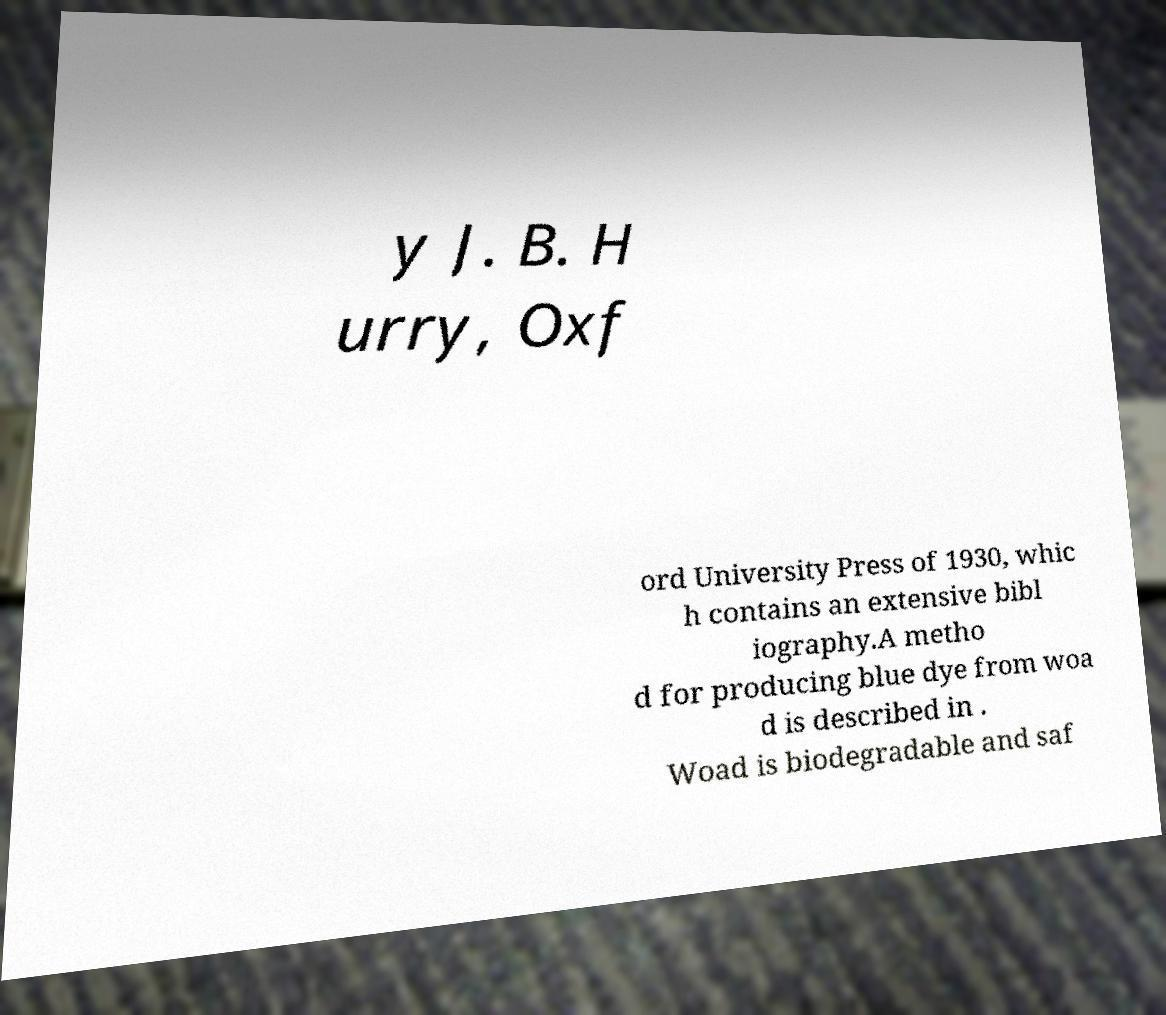For documentation purposes, I need the text within this image transcribed. Could you provide that? y J. B. H urry, Oxf ord University Press of 1930, whic h contains an extensive bibl iography.A metho d for producing blue dye from woa d is described in . Woad is biodegradable and saf 